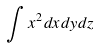<formula> <loc_0><loc_0><loc_500><loc_500>\int x ^ { 2 } d x d y d z</formula> 